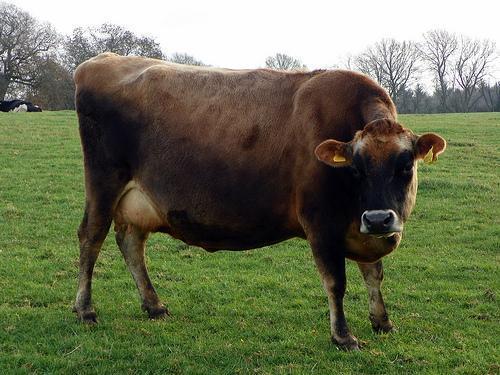How many black and white cows are in the picture?
Give a very brief answer. 1. How many yellow ear tags does the cow have?
Give a very brief answer. 2. 